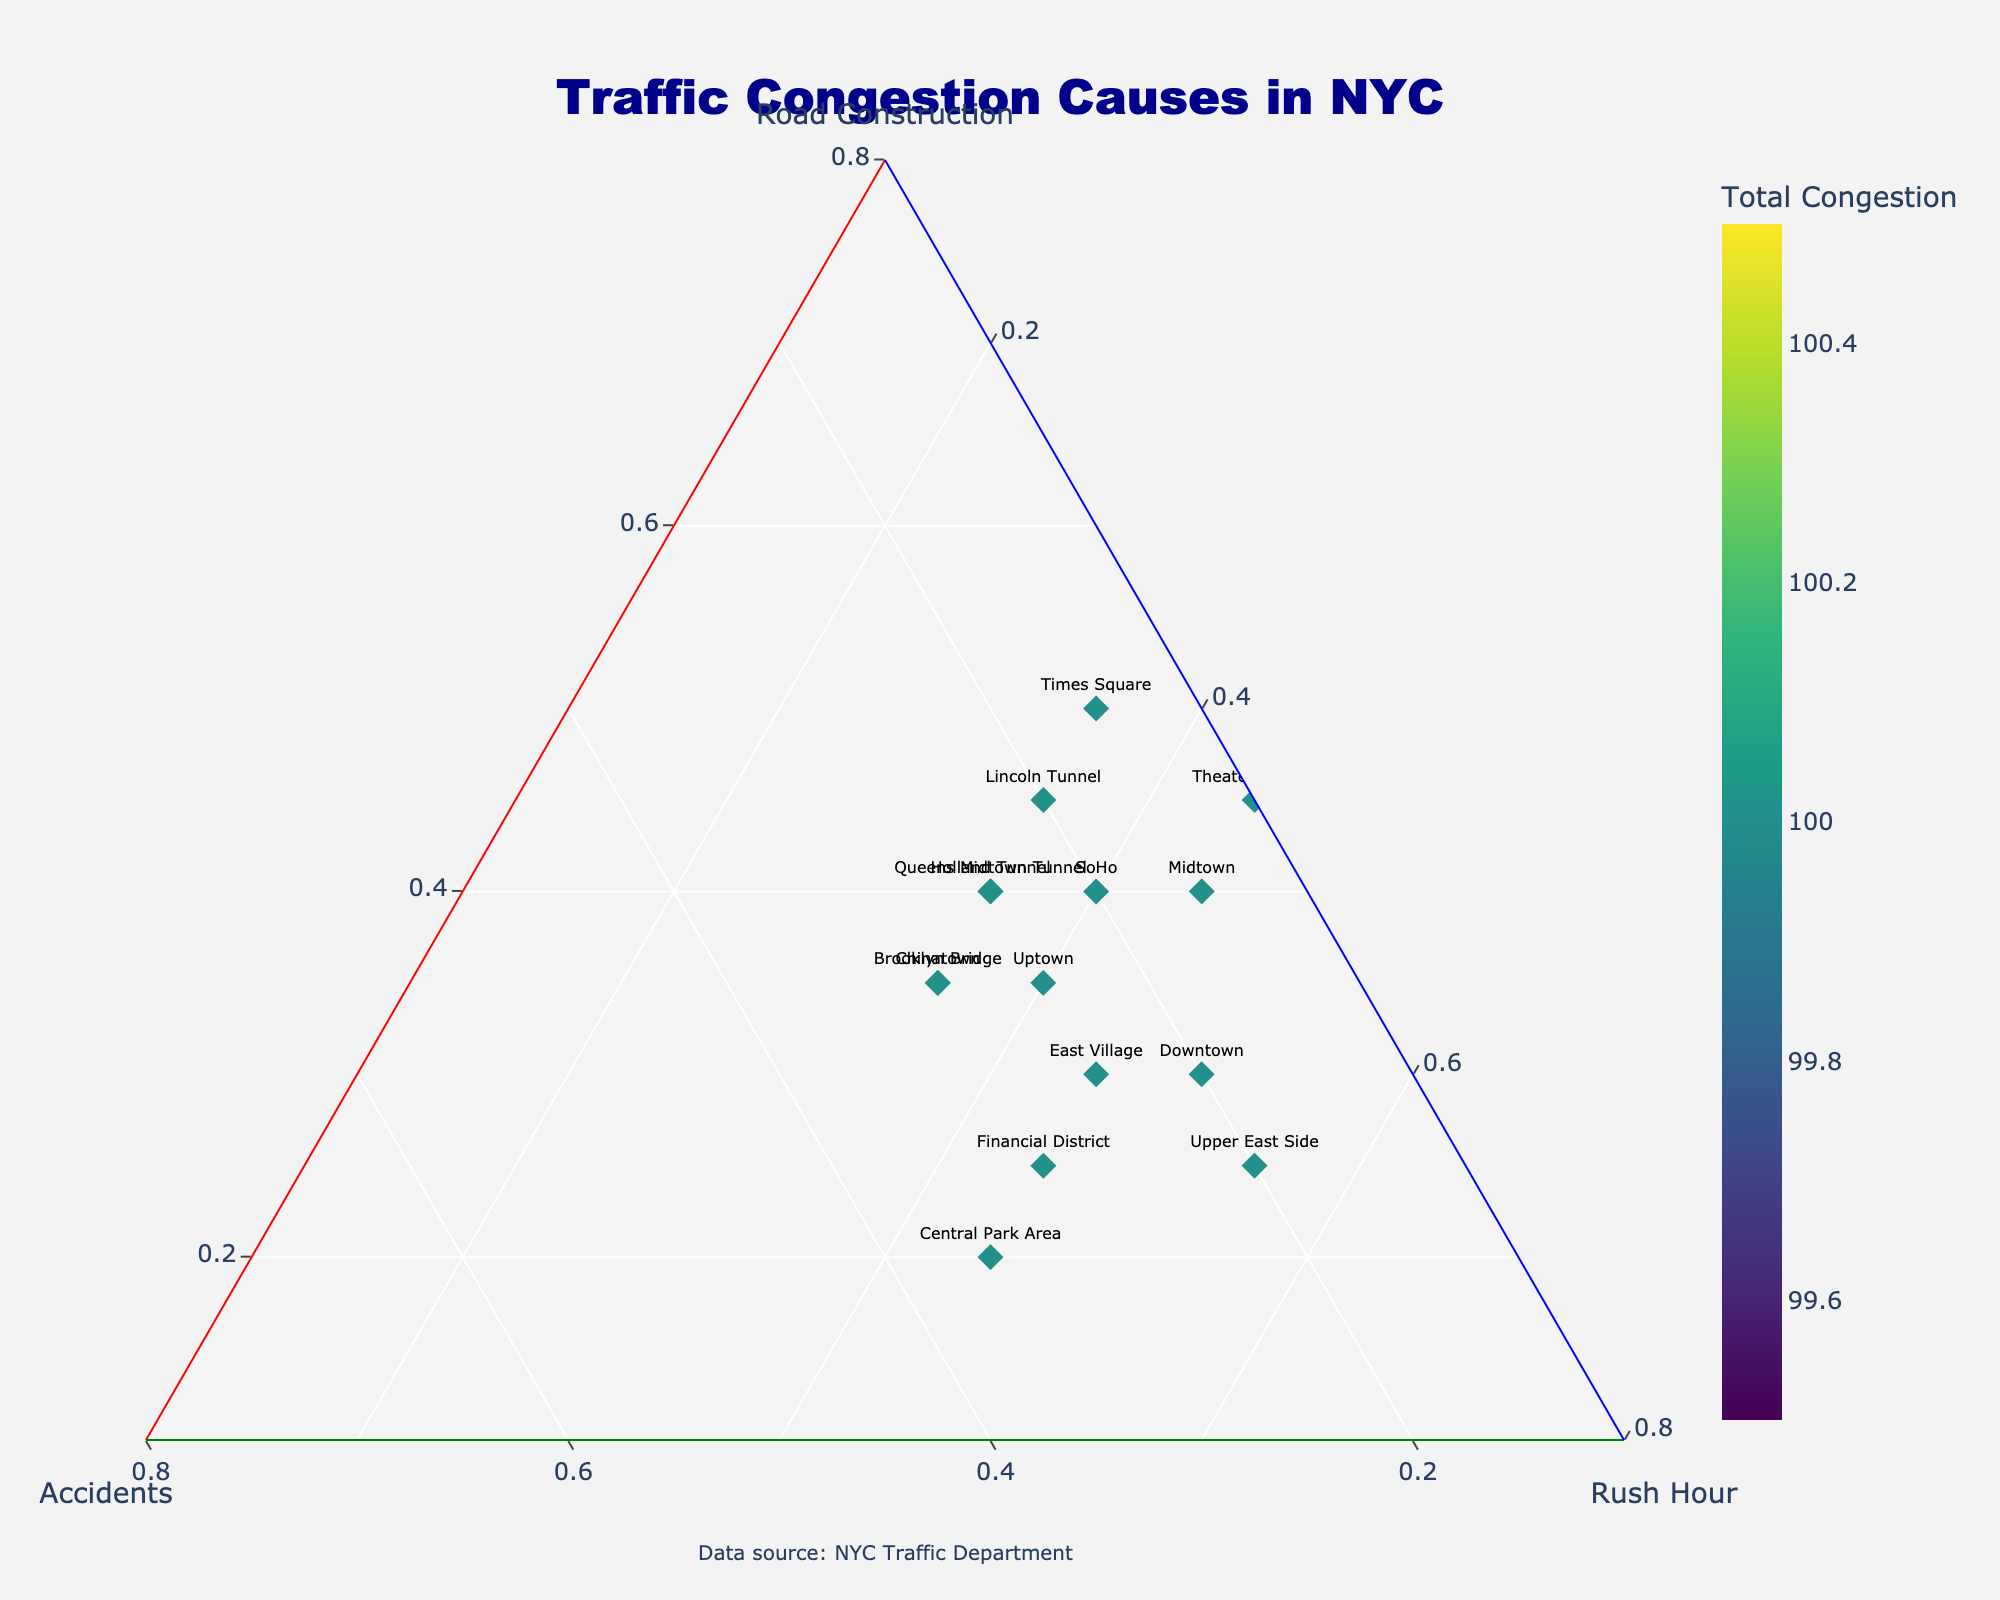What is the title of the figure? The title of a figure is usually found at the top of the chart. In this case, it’s clearly labeled above the ternary plot in large, bold text.
Answer: Traffic Congestion Causes in NYC How many data points are on the ternary plot? By counting each distinct marker labeled with a location on the ternary plot, we can determine the number of data points.
Answer: 15 Which area has the highest total congestion, and how is it indicated? The total congestion is indicated by the color and the color scale provided on the right side of the plot. By identifying the darkest color or highest value on the scale, we can identify the point with the highest total congestion.
Answer: Times Square What are the relative contributions of road construction, accidents, and rush hour to congestion in Midtown? Each axis represents one of the causes of congestion. By locating Midtown on the plot, we can note its exact position in relation to 'Road Construction', 'Accidents', and 'Rush Hour'.
Answer: Road Construction: 40%, Accidents: 15%, Rush Hour: 45% Which location has an equal contribution from road construction and accidents? An equal contribution from two causes means the marker will be positioned equidistantly between the two corresponding axes. We locate the points that line up equally from the 'Road Construction' and 'Accidents' axes to find the answer.
Answer: Chinatown and Brooklyn Bridge Between the Financial District and the Theater District, which has a higher contribution to congestion from accidents? By analyzing the positions of the Financial District and Theater District markers relative to the 'Accidents' axis, we can determine which has a higher contribution from accidents.
Answer: Financial District What location has the lowest contribution from road construction, and what is the approximate value? The location of points near the 'Accidents-Rush Hour' side of the ternary plot indicates lower road construction contribution since it trends toward its zero point.
Answer: Central Park Area, approximately 20% Which two locations have a similar total congestion but differ in the distribution of causes? By comparing colors (representing total congestion) and positions (representing distribution), we find the pairs with similar colors but different locations on the plot.
Answer: Lincoln Tunnel and Holland Tunnel For Uptown, calculate the combined percentage of congestion caused by road construction and accidents. We add the contributions of 'Road Construction' and 'Accidents' by locating Uptown on the plot and using their respective percentages.
Answer: 35% + 25% = 60% Which location has the highest contribution from rush hours, and what is its position on the plot? We look for the data point closest to the 'Rush Hour' vertex, as this indicates the highest contribution from rush hour patterns.
Answer: Upper East Side, near the 'Rush Hour' vertex 